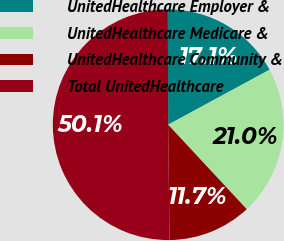Convert chart. <chart><loc_0><loc_0><loc_500><loc_500><pie_chart><fcel>UnitedHealthcare Employer &<fcel>UnitedHealthcare Medicare &<fcel>UnitedHealthcare Community &<fcel>Total UnitedHealthcare<nl><fcel>17.14%<fcel>20.98%<fcel>11.74%<fcel>50.15%<nl></chart> 